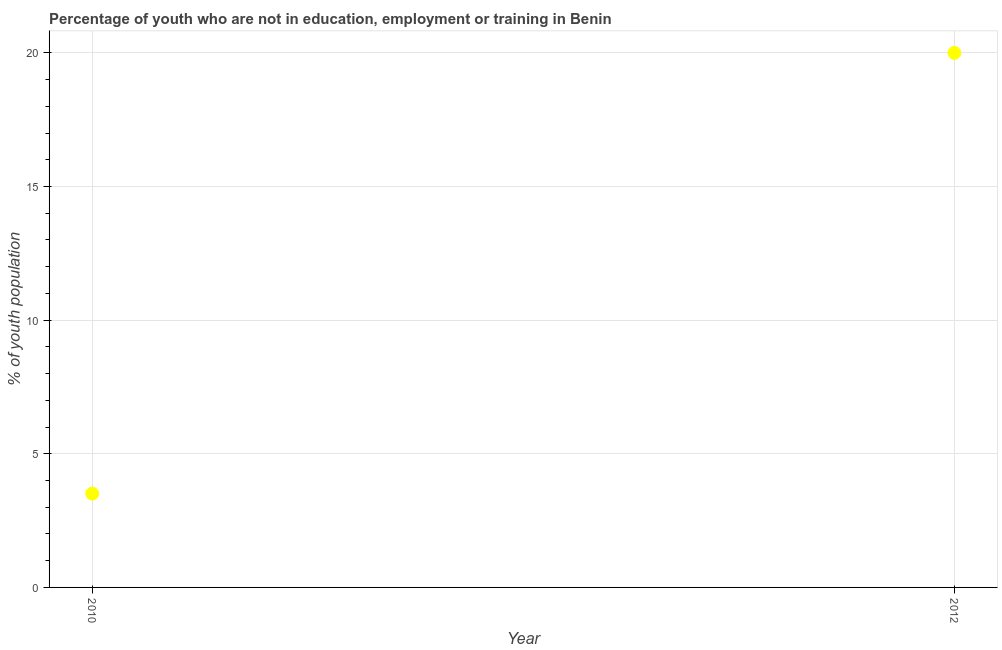Across all years, what is the maximum unemployed youth population?
Provide a short and direct response. 20. Across all years, what is the minimum unemployed youth population?
Ensure brevity in your answer.  3.51. In which year was the unemployed youth population minimum?
Your response must be concise. 2010. What is the sum of the unemployed youth population?
Provide a short and direct response. 23.51. What is the difference between the unemployed youth population in 2010 and 2012?
Make the answer very short. -16.49. What is the average unemployed youth population per year?
Your response must be concise. 11.75. What is the median unemployed youth population?
Keep it short and to the point. 11.75. In how many years, is the unemployed youth population greater than 14 %?
Give a very brief answer. 1. What is the ratio of the unemployed youth population in 2010 to that in 2012?
Offer a very short reply. 0.18. In how many years, is the unemployed youth population greater than the average unemployed youth population taken over all years?
Provide a succinct answer. 1. Does the unemployed youth population monotonically increase over the years?
Offer a terse response. Yes. How many years are there in the graph?
Your response must be concise. 2. What is the title of the graph?
Ensure brevity in your answer.  Percentage of youth who are not in education, employment or training in Benin. What is the label or title of the X-axis?
Keep it short and to the point. Year. What is the label or title of the Y-axis?
Your response must be concise. % of youth population. What is the % of youth population in 2010?
Ensure brevity in your answer.  3.51. What is the difference between the % of youth population in 2010 and 2012?
Your response must be concise. -16.49. What is the ratio of the % of youth population in 2010 to that in 2012?
Your answer should be compact. 0.17. 